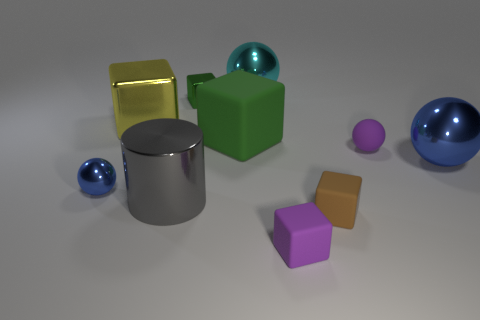Subtract all large cyan shiny balls. How many balls are left? 3 Subtract all cylinders. How many objects are left? 9 Subtract all brown cubes. How many blue balls are left? 2 Subtract all yellow cubes. How many cubes are left? 4 Subtract all tiny matte cubes. Subtract all brown rubber cubes. How many objects are left? 7 Add 9 gray shiny things. How many gray shiny things are left? 10 Add 1 blue shiny spheres. How many blue shiny spheres exist? 3 Subtract 0 brown balls. How many objects are left? 10 Subtract 3 spheres. How many spheres are left? 1 Subtract all brown cubes. Subtract all blue balls. How many cubes are left? 4 